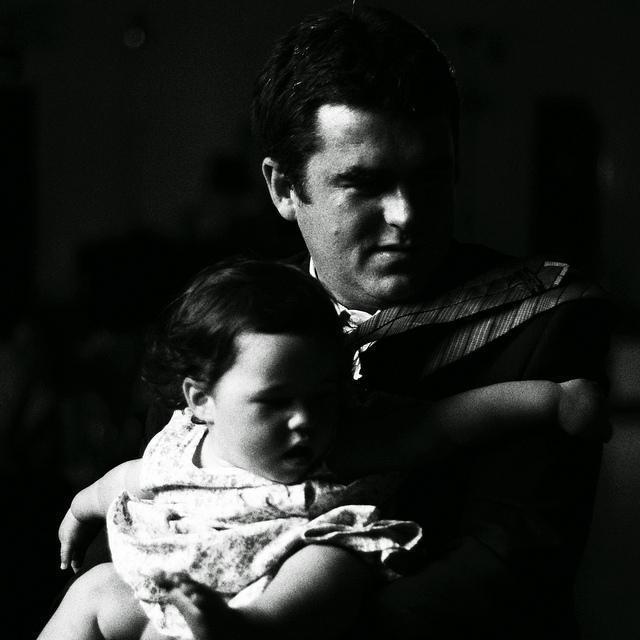How many people are in this image?
Give a very brief answer. 2. How many people are there?
Give a very brief answer. 2. 